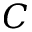Convert formula to latex. <formula><loc_0><loc_0><loc_500><loc_500>C</formula> 